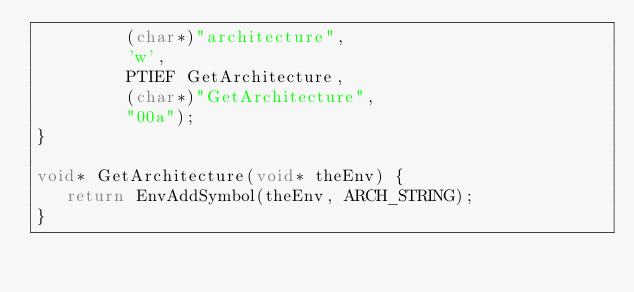Convert code to text. <code><loc_0><loc_0><loc_500><loc_500><_C_>         (char*)"architecture",
         'w',
         PTIEF GetArchitecture,
         (char*)"GetArchitecture",
         "00a");
}

void* GetArchitecture(void* theEnv) {
   return EnvAddSymbol(theEnv, ARCH_STRING);
}
</code> 